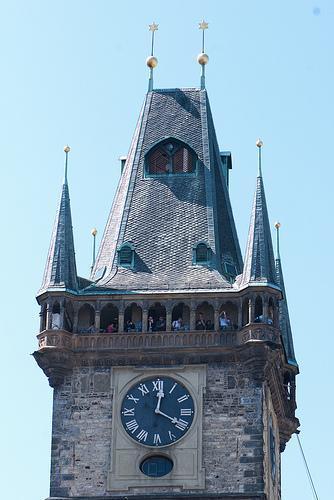How many clocks are there?
Give a very brief answer. 1. 